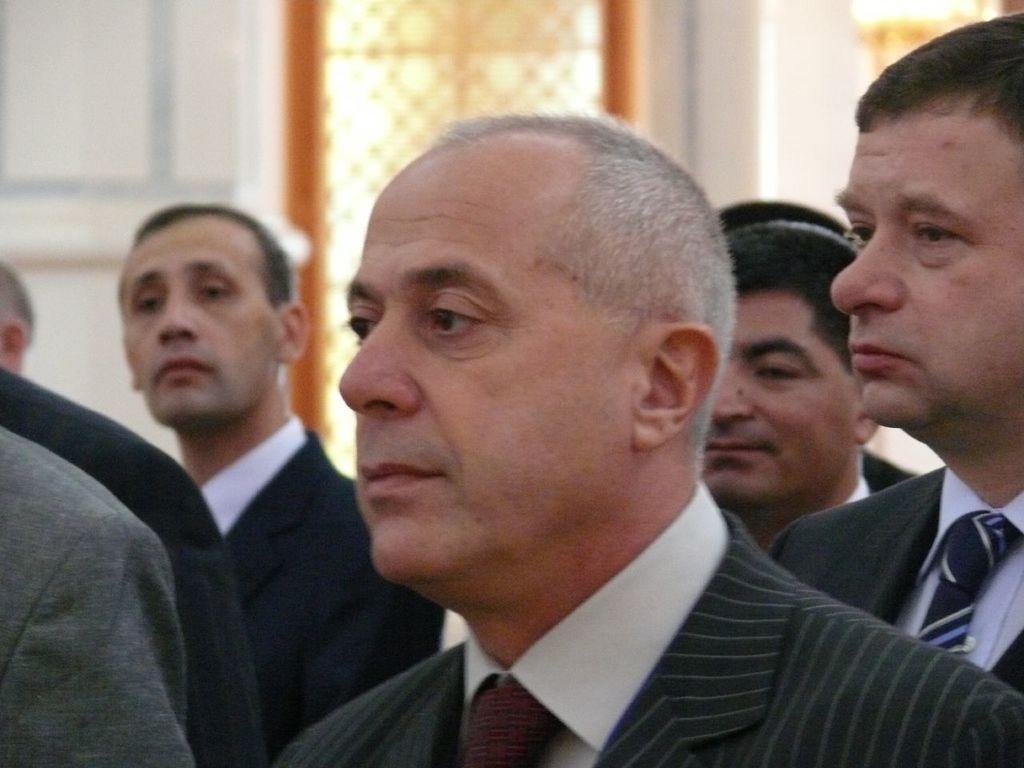In one or two sentences, can you explain what this image depicts? Here in this picture we can see a group of men standing over a place and all of them are wearing suits on them over there. 